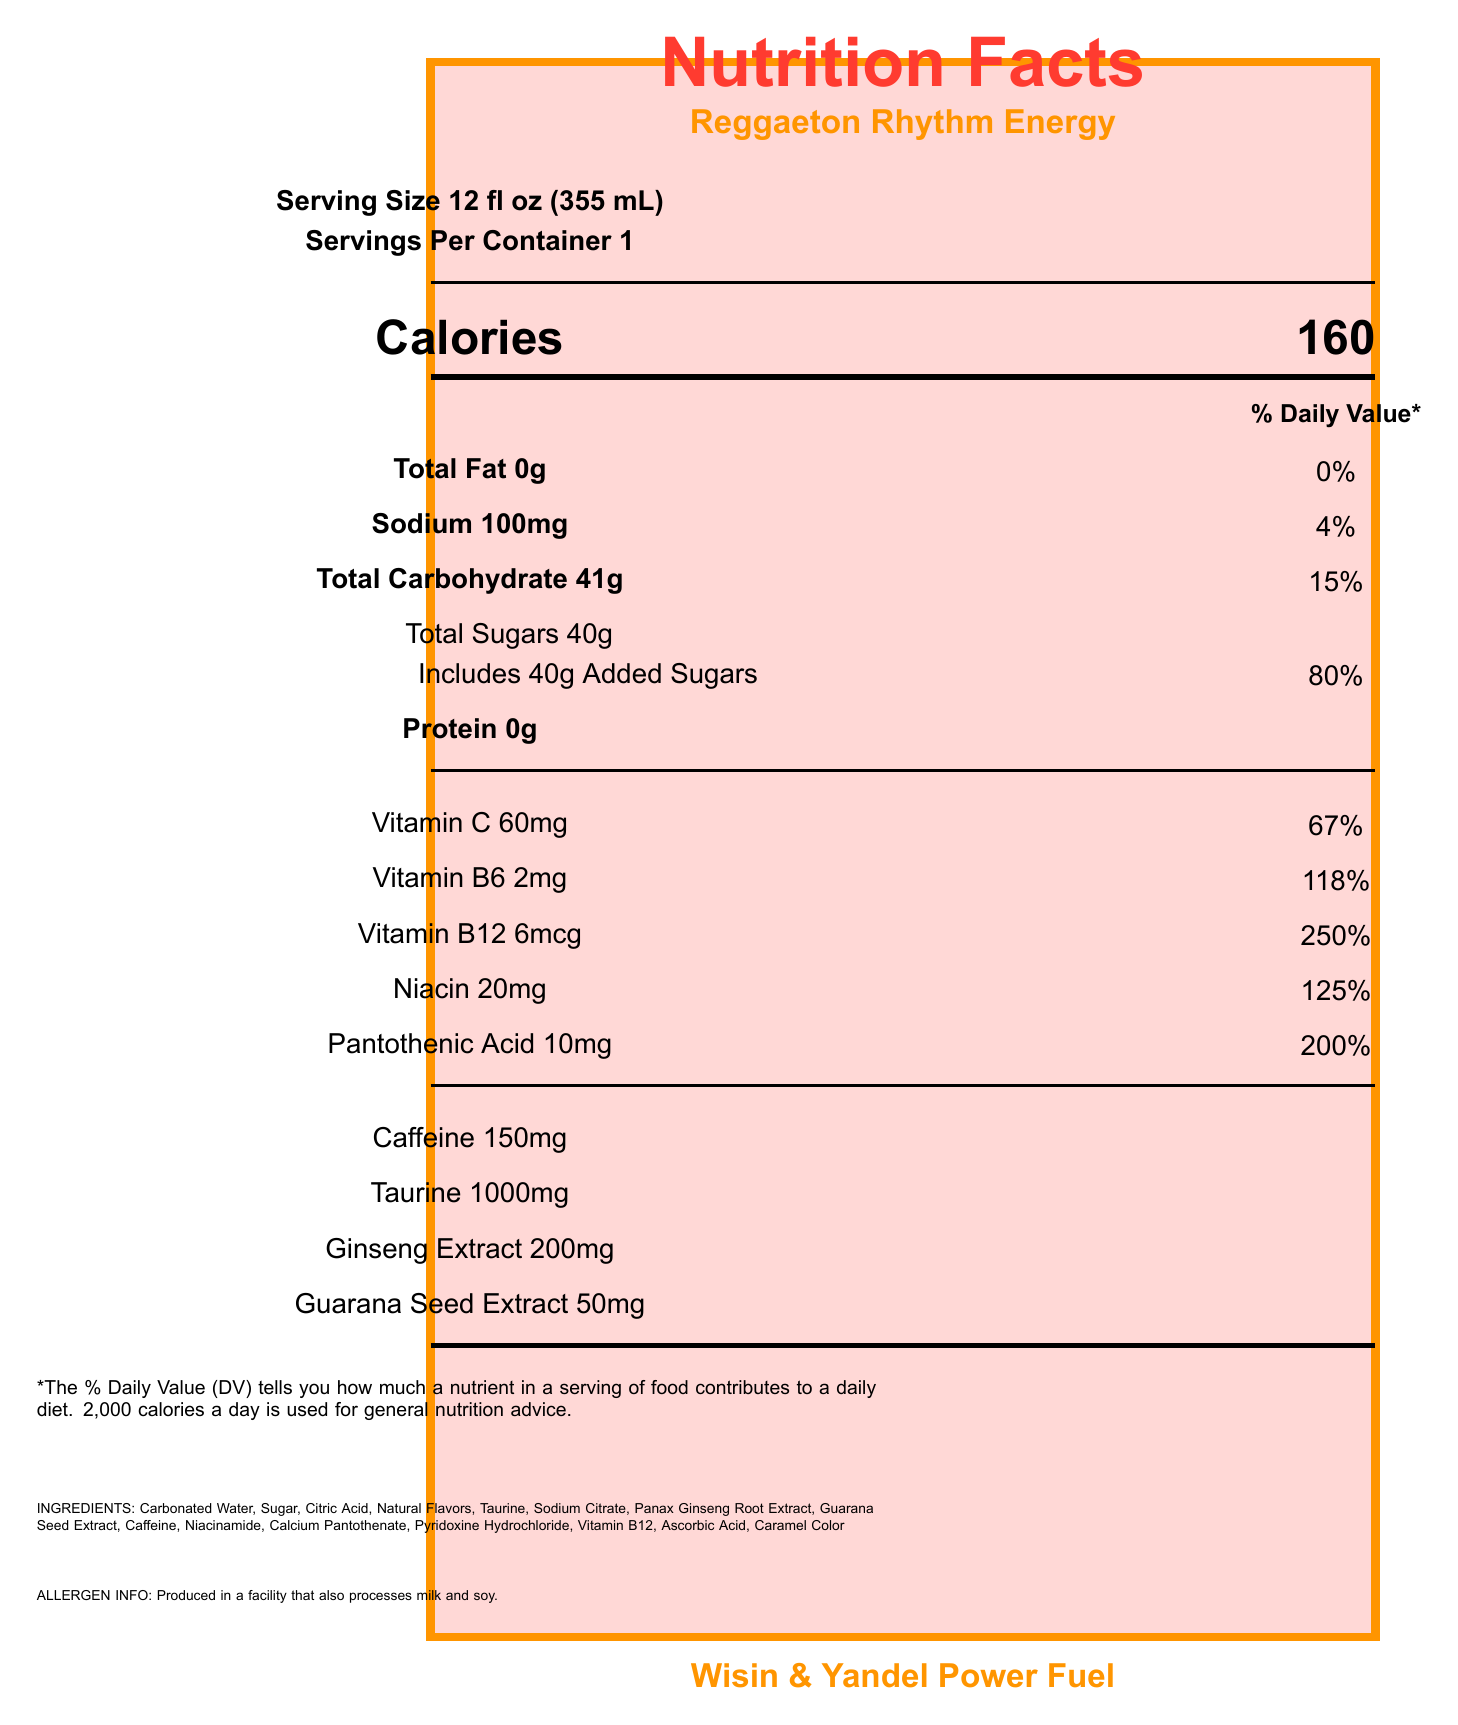what is the serving size? The serving size is explicitly mentioned under the "Serving information" section of the document.
Answer: 12 fl oz (355 mL) how many calories are in one serving of Reggaeton Rhythm Energy? The calorie count is clearly indicated in the "Calorie information" section of the document.
Answer: 160 how much vitamin B12 does one serving contain? The amount of vitamin B12 is listed under the "Nutrient information" section with all other vitamins.
Answer: 6mcg what is the percentage daily value of niacin in one serving? The daily value percentage for niacin is stated next to its amount in the "Nutrient information" section.
Answer: 125% how much sugar is in this energy drink? The amount of total sugars is included under the "Total Sugars" section in the "Nutrient information".
Answer: 40g which ingredient is present in the highest quantity? A. Sugar B. Taurine C. Guarana Seed Extract D. Caramel Color "Sugar" is listed second after Carbonated Water, indicating it likely has the highest quantity by position order.
Answer: A what is the caffeine content per serving? A. 100mg B. 150mg C. 200mg D. 250mg The "Nutrient information" states that the caffeine content is 150mg.
Answer: B is this product suitable for children? The disclaimer states, "Not recommended for children, pregnant or nursing women, or those sensitive to caffeine."
Answer: No summarize the main idea of the document. The document is formatted to visually emphasize the nutritional breakdown and key features of the energy drink, ensuring consumers can make informed choices.
Answer: The document provides detailed nutrition information for the "Reggaeton Rhythm Energy" drink by Wisin & Yandel, including serving size, calories, detailed nutrient content, and ingredient list. It also includes allergen information, a disclaimer about who should avoid the product, and a promotional message. is there any information on fat content? The document indicates that the total fat content is 0g with a daily value of 0%.
Answer: Yes is the product manufactured and distributed from the same location? The document provides the manufacturer's name (Reggaeton Rhythm Beverages, Inc.) and the distribution location (San Juan, Puerto Rico 00901), but it does not specify the manufacturing location.
Answer: Not enough information what percentage of the daily value of vitamin C is in one serving? The percentage daily value for vitamin C is listed next to its amount in the "Nutrient information" section.
Answer: 67% what is the brand name of the product? The brand name is mentioned at the bottom with "Wisin & Yandel Power Fuel" branding.
Answer: Wisin & Yandel Power Fuel 